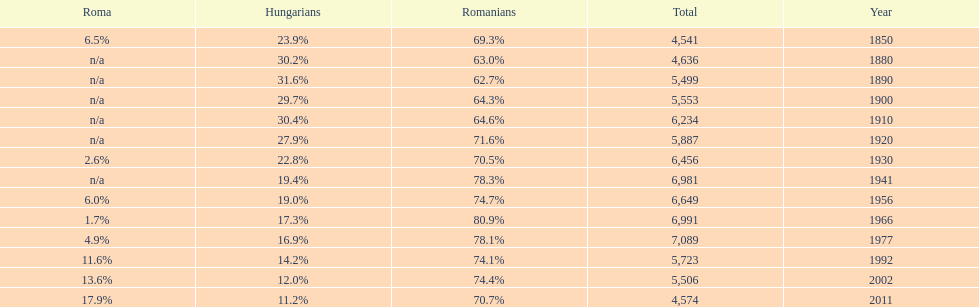In what year was there the largest percentage of hungarians? 1890. 